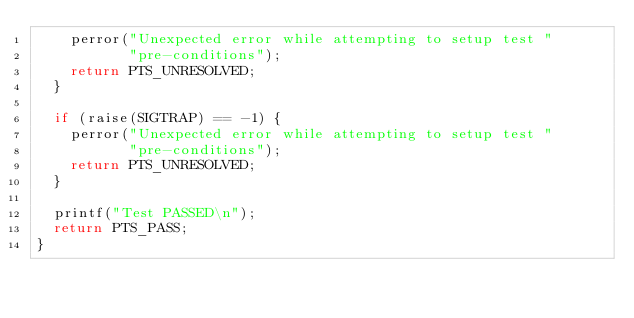<code> <loc_0><loc_0><loc_500><loc_500><_C_>		perror("Unexpected error while attempting to setup test "
		       "pre-conditions");
		return PTS_UNRESOLVED;
	}

	if (raise(SIGTRAP) == -1) {
		perror("Unexpected error while attempting to setup test "
		       "pre-conditions");
		return PTS_UNRESOLVED;
	}

	printf("Test PASSED\n");
	return PTS_PASS;	
}

</code> 